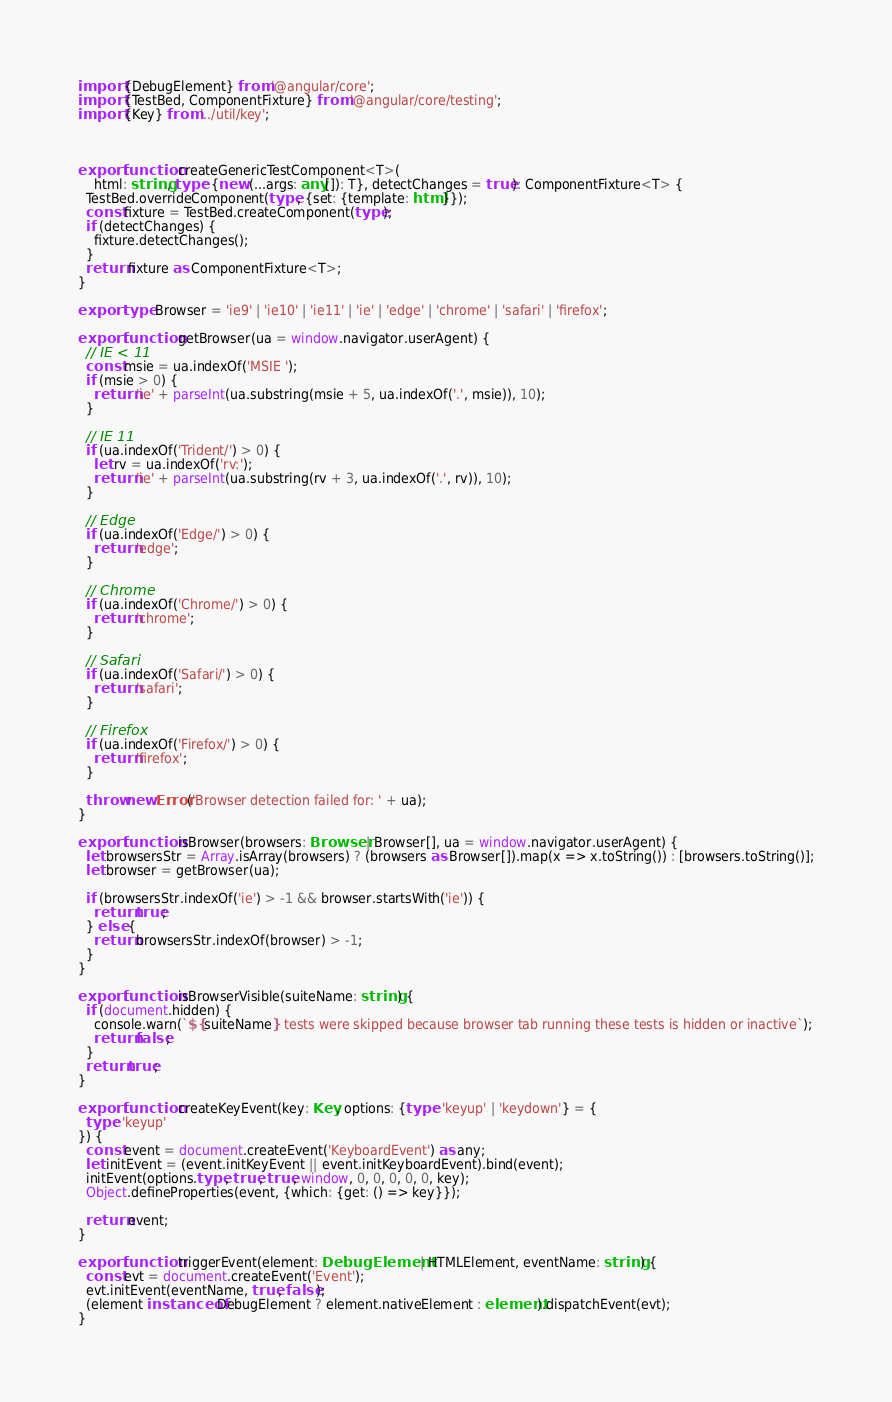<code> <loc_0><loc_0><loc_500><loc_500><_TypeScript_>import {DebugElement} from '@angular/core';
import {TestBed, ComponentFixture} from '@angular/core/testing';
import {Key} from '../util/key';



export function createGenericTestComponent<T>(
    html: string, type: {new (...args: any[]): T}, detectChanges = true): ComponentFixture<T> {
  TestBed.overrideComponent(type, {set: {template: html}});
  const fixture = TestBed.createComponent(type);
  if (detectChanges) {
    fixture.detectChanges();
  }
  return fixture as ComponentFixture<T>;
}

export type Browser = 'ie9' | 'ie10' | 'ie11' | 'ie' | 'edge' | 'chrome' | 'safari' | 'firefox';

export function getBrowser(ua = window.navigator.userAgent) {
  // IE < 11
  const msie = ua.indexOf('MSIE ');
  if (msie > 0) {
    return 'ie' + parseInt(ua.substring(msie + 5, ua.indexOf('.', msie)), 10);
  }

  // IE 11
  if (ua.indexOf('Trident/') > 0) {
    let rv = ua.indexOf('rv:');
    return 'ie' + parseInt(ua.substring(rv + 3, ua.indexOf('.', rv)), 10);
  }

  // Edge
  if (ua.indexOf('Edge/') > 0) {
    return 'edge';
  }

  // Chrome
  if (ua.indexOf('Chrome/') > 0) {
    return 'chrome';
  }

  // Safari
  if (ua.indexOf('Safari/') > 0) {
    return 'safari';
  }

  // Firefox
  if (ua.indexOf('Firefox/') > 0) {
    return 'firefox';
  }

  throw new Error('Browser detection failed for: ' + ua);
}

export function isBrowser(browsers: Browser | Browser[], ua = window.navigator.userAgent) {
  let browsersStr = Array.isArray(browsers) ? (browsers as Browser[]).map(x => x.toString()) : [browsers.toString()];
  let browser = getBrowser(ua);

  if (browsersStr.indexOf('ie') > -1 && browser.startsWith('ie')) {
    return true;
  } else {
    return browsersStr.indexOf(browser) > -1;
  }
}

export function isBrowserVisible(suiteName: string) {
  if (document.hidden) {
    console.warn(`${suiteName} tests were skipped because browser tab running these tests is hidden or inactive`);
    return false;
  }
  return true;
}

export function createKeyEvent(key: Key, options: {type: 'keyup' | 'keydown'} = {
  type: 'keyup'
}) {
  const event = document.createEvent('KeyboardEvent') as any;
  let initEvent = (event.initKeyEvent || event.initKeyboardEvent).bind(event);
  initEvent(options.type, true, true, window, 0, 0, 0, 0, 0, key);
  Object.defineProperties(event, {which: {get: () => key}});

  return event;
}

export function triggerEvent(element: DebugElement | HTMLElement, eventName: string) {
  const evt = document.createEvent('Event');
  evt.initEvent(eventName, true, false);
  (element instanceof DebugElement ? element.nativeElement : element).dispatchEvent(evt);
}
</code> 